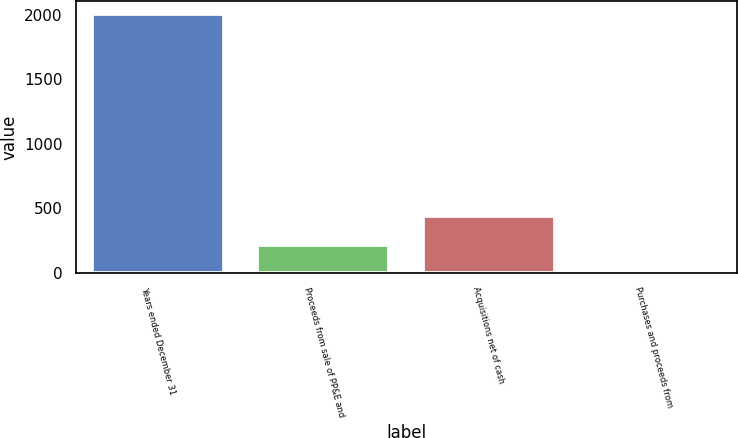Convert chart. <chart><loc_0><loc_0><loc_500><loc_500><bar_chart><fcel>Years ended December 31<fcel>Proceeds from sale of PP&E and<fcel>Acquisitions net of cash<fcel>Purchases and proceeds from<nl><fcel>2003<fcel>216.5<fcel>439<fcel>18<nl></chart> 